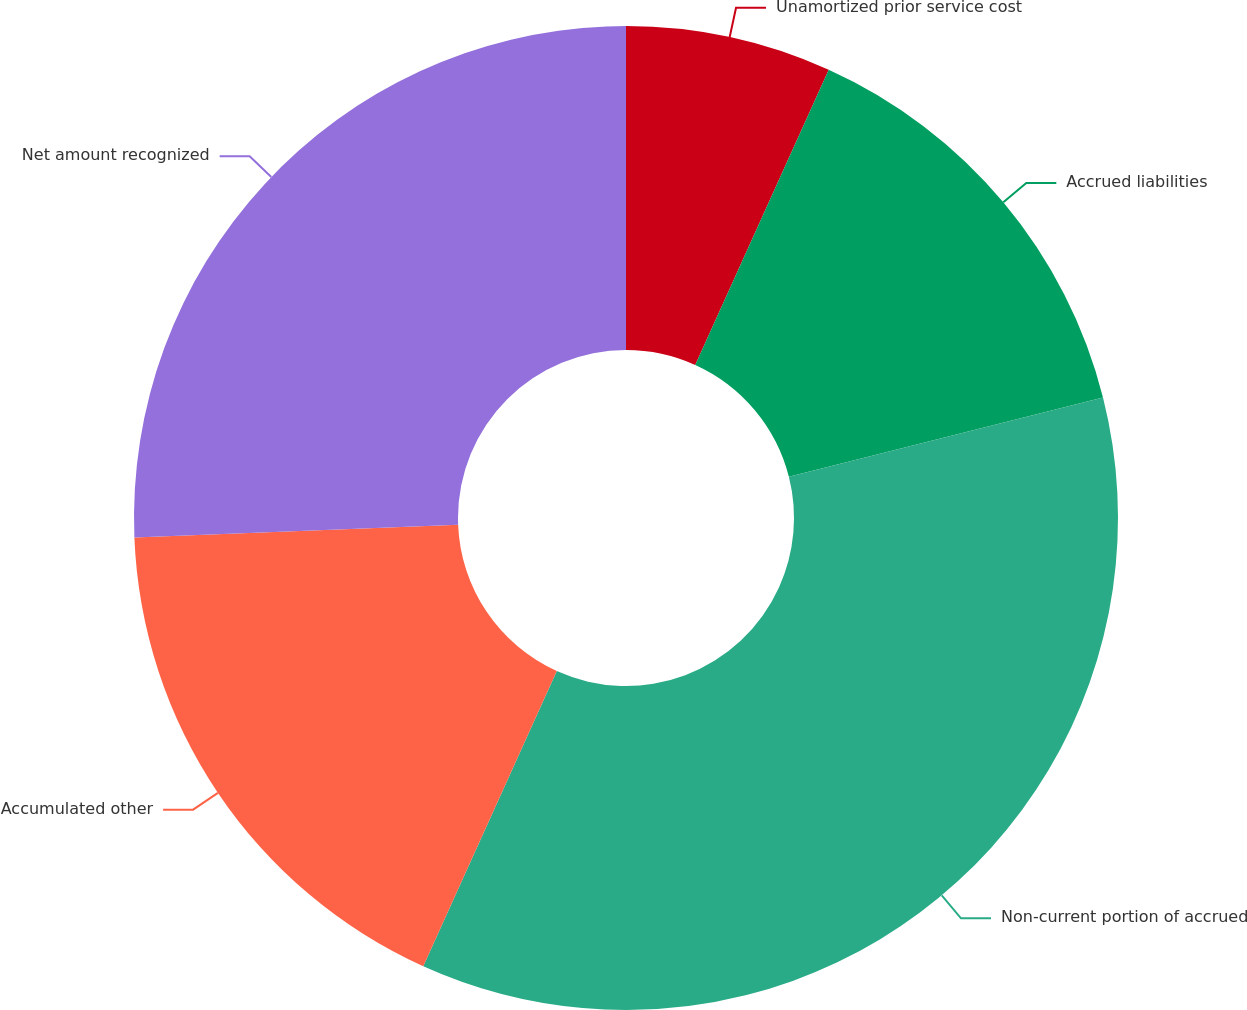Convert chart to OTSL. <chart><loc_0><loc_0><loc_500><loc_500><pie_chart><fcel>Unamortized prior service cost<fcel>Accrued liabilities<fcel>Non-current portion of accrued<fcel>Accumulated other<fcel>Net amount recognized<nl><fcel>6.76%<fcel>14.3%<fcel>35.7%<fcel>17.61%<fcel>25.63%<nl></chart> 